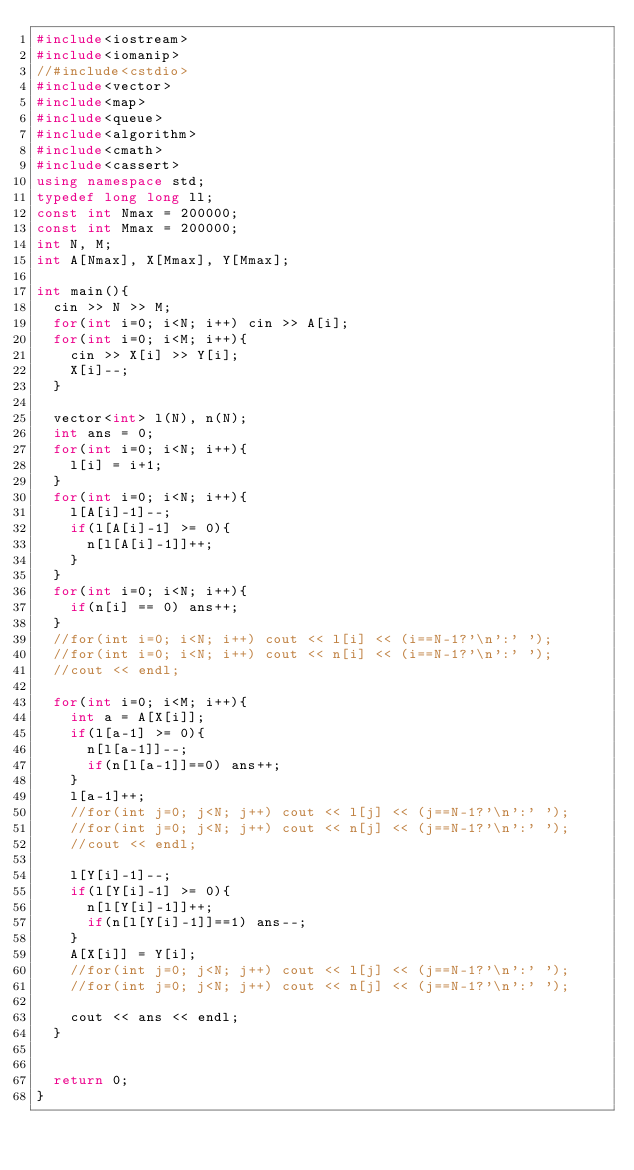<code> <loc_0><loc_0><loc_500><loc_500><_C++_>#include<iostream>
#include<iomanip>
//#include<cstdio>
#include<vector>
#include<map>
#include<queue>
#include<algorithm>
#include<cmath>
#include<cassert>
using namespace std;
typedef long long ll;
const int Nmax = 200000;
const int Mmax = 200000;
int N, M;
int A[Nmax], X[Mmax], Y[Mmax];

int main(){
	cin >> N >> M;
	for(int i=0; i<N; i++) cin >> A[i];
	for(int i=0; i<M; i++){
		cin >> X[i] >> Y[i];
		X[i]--;
	}

	vector<int> l(N), n(N);
	int ans = 0;
	for(int i=0; i<N; i++){
		l[i] = i+1;
	}
	for(int i=0; i<N; i++){
		l[A[i]-1]--;
		if(l[A[i]-1] >= 0){
			n[l[A[i]-1]]++;
		}
	}
	for(int i=0; i<N; i++){
		if(n[i] == 0) ans++;
	}
	//for(int i=0; i<N; i++) cout << l[i] << (i==N-1?'\n':' ');
	//for(int i=0; i<N; i++) cout << n[i] << (i==N-1?'\n':' ');
	//cout << endl;

	for(int i=0; i<M; i++){
		int a = A[X[i]];
		if(l[a-1] >= 0){
			n[l[a-1]]--;
			if(n[l[a-1]]==0) ans++;
		}
		l[a-1]++;
		//for(int j=0; j<N; j++) cout << l[j] << (j==N-1?'\n':' ');
		//for(int j=0; j<N; j++) cout << n[j] << (j==N-1?'\n':' ');
		//cout << endl;

		l[Y[i]-1]--;
		if(l[Y[i]-1] >= 0){
			n[l[Y[i]-1]]++;
			if(n[l[Y[i]-1]]==1) ans--;
		}
		A[X[i]] = Y[i];
		//for(int j=0; j<N; j++) cout << l[j] << (j==N-1?'\n':' ');
		//for(int j=0; j<N; j++) cout << n[j] << (j==N-1?'\n':' ');

		cout << ans << endl;
	}


	return 0;
}
</code> 